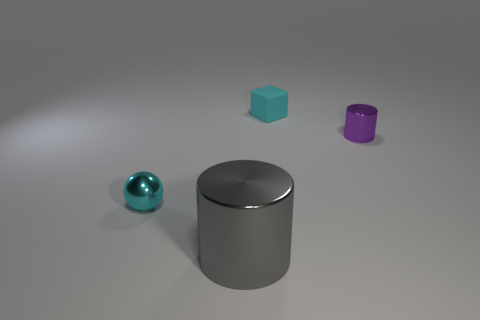Are there any other things that have the same shape as the tiny cyan rubber thing?
Keep it short and to the point. No. What color is the thing that is to the right of the cyan thing that is to the right of the shiny cylinder to the left of the block?
Your answer should be compact. Purple. There is a block that is the same size as the metal ball; what material is it?
Make the answer very short. Rubber. What number of other big objects are the same material as the big gray object?
Your response must be concise. 0. There is a metallic cylinder right of the cyan rubber cube; is it the same size as the metal cylinder that is on the left side of the rubber block?
Provide a short and direct response. No. The tiny metal thing that is right of the cyan matte cube is what color?
Your answer should be very brief. Purple. What material is the small thing that is the same color as the ball?
Ensure brevity in your answer.  Rubber. What number of tiny metal balls are the same color as the small matte object?
Provide a short and direct response. 1. Is the size of the cyan cube the same as the cyan object in front of the small metal cylinder?
Provide a short and direct response. Yes. There is a metal cylinder in front of the small shiny thing to the left of the shiny cylinder that is to the left of the small shiny cylinder; what size is it?
Your answer should be compact. Large. 